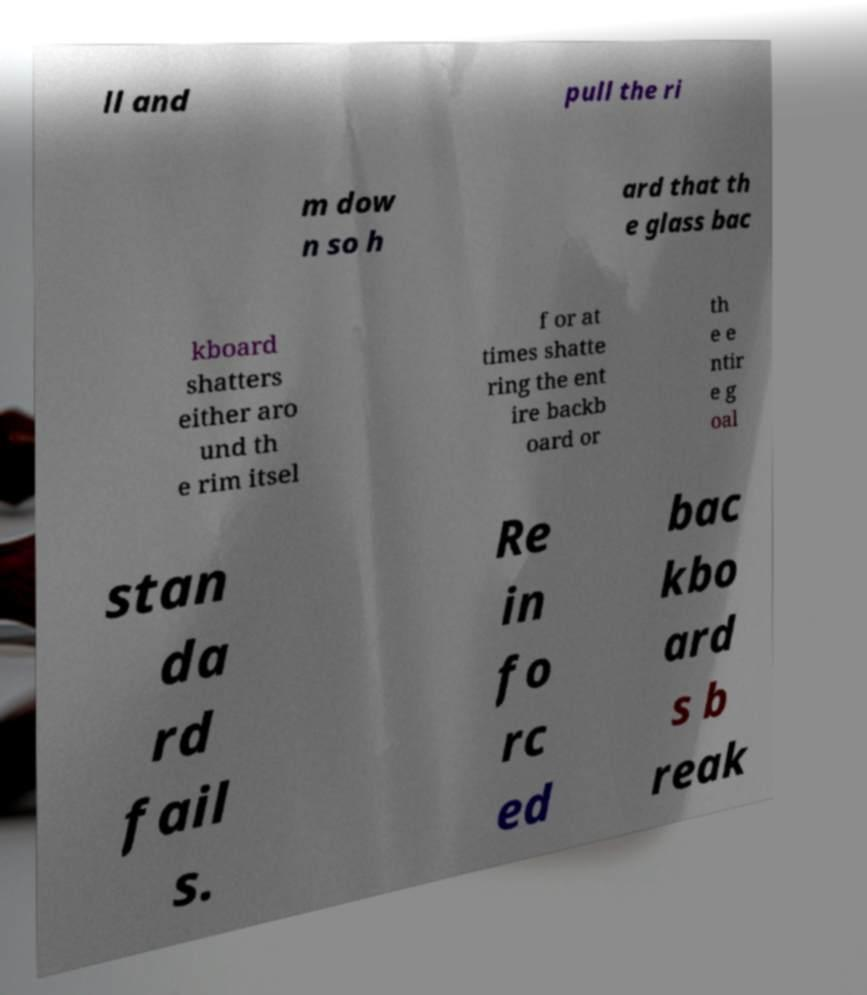Could you assist in decoding the text presented in this image and type it out clearly? ll and pull the ri m dow n so h ard that th e glass bac kboard shatters either aro und th e rim itsel f or at times shatte ring the ent ire backb oard or th e e ntir e g oal stan da rd fail s. Re in fo rc ed bac kbo ard s b reak 